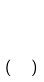<formula> <loc_0><loc_0><loc_500><loc_500>( \begin{matrix} 2 \\ 4 \end{matrix} )</formula> 